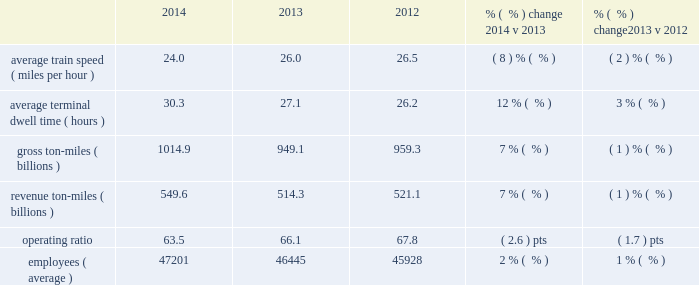Interest expense 2013 interest expense increased in 2014 versus 2013 due to an increased weighted- average debt level of $ 10.8 billion in 2014 from $ 9.6 billion in 2013 , which more than offset the impact of the lower effective interest rate of 5.3% ( 5.3 % ) in 2014 versus 5.7% ( 5.7 % ) in 2013 .
Interest expense decreased in 2013 versus 2012 due to a lower effective interest rate of 5.7% ( 5.7 % ) in 2013 versus 6.0% ( 6.0 % ) in 2012 .
The increase in the weighted-average debt level to $ 9.6 billion in 2013 from $ 9.1 billion in 2012 partially offset the impact of the lower effective interest rate .
Income taxes 2013 higher pre-tax income increased income taxes in 2014 compared to 2013 .
Our effective tax rate for 2014 was 37.9% ( 37.9 % ) compared to 37.7% ( 37.7 % ) in 2013 .
Higher pre-tax income increased income taxes in 2013 compared to 2012 .
Our effective tax rate for 2013 was 37.7% ( 37.7 % ) compared to 37.6% ( 37.6 % ) in 2012 .
Other operating/performance and financial statistics we report a number of key performance measures weekly to the association of american railroads ( aar ) .
We provide this data on our website at www.up.com/investor/aar-stb_reports/index.htm .
Operating/performance statistics railroad performance measures are included in the table below : 2014 2013 2012 % (  % ) change 2014 v 2013 % (  % ) change 2013 v 2012 .
Average train speed 2013 average train speed is calculated by dividing train miles by hours operated on our main lines between terminals .
Average train speed , as reported to the association of american railroads , decreased 8% ( 8 % ) in 2014 versus 2013 .
The decline was driven by a 7% ( 7 % ) volume increase , a major infrastructure project in fort worth , texas and inclement weather , including flooding in the midwest in the second quarter and severe weather conditions in the first quarter that impacted all major u.s .
And canadian railroads .
Average train speed decreased 2% ( 2 % ) in 2013 versus 2012 .
The decline was driven by severe weather conditions and shifts of traffic to sections of our network with higher utilization .
Average terminal dwell time 2013 average terminal dwell time is the average time that a rail car spends at our terminals .
Lower average terminal dwell time improves asset utilization and service .
Average terminal dwell time increased 12% ( 12 % ) in 2014 compared to 2013 , caused by higher volumes and inclement weather .
Average terminal dwell time increased 3% ( 3 % ) in 2013 compared to 2012 , primarily due to growth of manifest traffic which requires more time in terminals for switching cars and building trains .
Gross and revenue ton-miles 2013 gross ton-miles are calculated by multiplying the weight of loaded and empty freight cars by the number of miles hauled .
Revenue ton-miles are calculated by multiplying the weight of freight by the number of tariff miles .
Gross ton-miles , revenue ton-miles and carloadings all increased 7% ( 7 % ) in 2014 compared to 2013 .
Gross ton-miles and revenue ton-miles declined 1% ( 1 % ) in 2013 compared to 2012 and carloads remained relatively flat driven by declines in coal and agricultural products offset by growth in chemical , autos and industrial products .
Changes in commodity mix drove the year-over-year variances between gross ton- miles , revenue ton-miles and carloads. .
If average train speed ( miles per hour ) increased at the same rate as carloadings , what would the speed have been for 2014? 
Computations: (26.0 + 7%)
Answer: 26.07. 